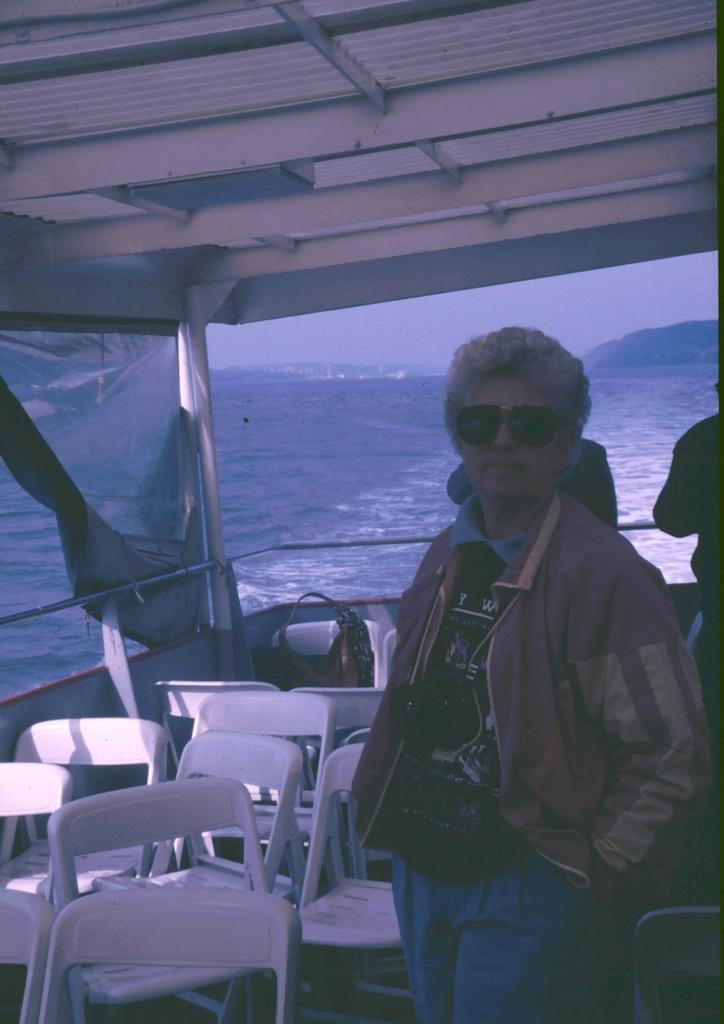Who or what can be seen in the image? There are people in the image. What are the people sitting on in the image? There are chairs in the image. What can be seen in the distance in the image? There is water visible in the background of the image. What type of cable is being used by the people in the image? There is no cable present in the image. How does the carriage in the image help the people travel? There is no carriage present in the image. 